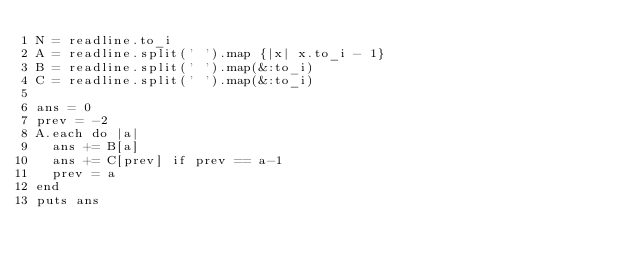<code> <loc_0><loc_0><loc_500><loc_500><_Ruby_>N = readline.to_i
A = readline.split(' ').map {|x| x.to_i - 1}
B = readline.split(' ').map(&:to_i)
C = readline.split(' ').map(&:to_i)

ans = 0
prev = -2
A.each do |a|
  ans += B[a]
  ans += C[prev] if prev == a-1
  prev = a
end
puts ans

</code> 